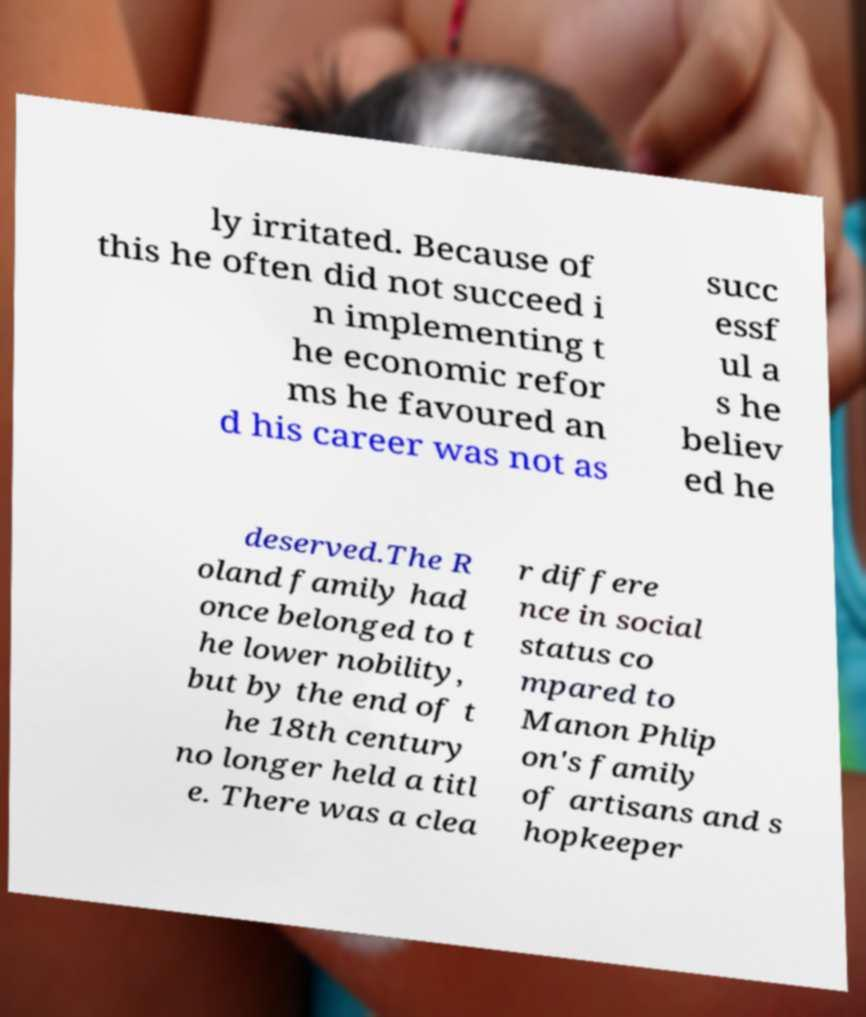Could you assist in decoding the text presented in this image and type it out clearly? ly irritated. Because of this he often did not succeed i n implementing t he economic refor ms he favoured an d his career was not as succ essf ul a s he believ ed he deserved.The R oland family had once belonged to t he lower nobility, but by the end of t he 18th century no longer held a titl e. There was a clea r differe nce in social status co mpared to Manon Phlip on's family of artisans and s hopkeeper 